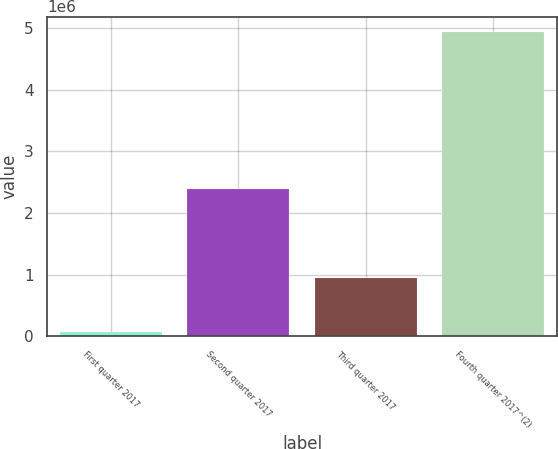Convert chart to OTSL. <chart><loc_0><loc_0><loc_500><loc_500><bar_chart><fcel>First quarter 2017<fcel>Second quarter 2017<fcel>Third quarter 2017<fcel>Fourth quarter 2017^(2)<nl><fcel>63812<fcel>2.38432e+06<fcel>951866<fcel>4.94241e+06<nl></chart> 